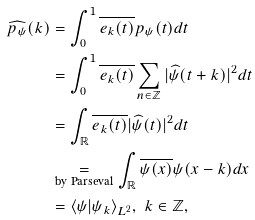Convert formula to latex. <formula><loc_0><loc_0><loc_500><loc_500>\widehat { p _ { \psi } } ( k ) & = \int _ { 0 } ^ { 1 } \overline { e _ { k } ( t ) } p _ { \psi } ( t ) d t \\ & = \int _ { 0 } ^ { 1 } \overline { e _ { k } ( t ) } \sum _ { n \in \mathbb { Z } } | \widehat { \psi } ( t + k ) | ^ { 2 } d t \\ & = \int _ { \mathbb { R } } \overline { e _ { k } ( t ) } | \widehat { \psi } ( t ) | ^ { 2 } d t \\ & \underset { \text {by Parseval} } { = } \int _ { \mathbb { R } } \overline { \psi ( x ) } \psi ( x - k ) d x \\ & = \langle \psi | \psi _ { k } \rangle _ { L ^ { 2 } } , \text { } k \in \mathbb { Z } ,</formula> 